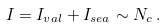Convert formula to latex. <formula><loc_0><loc_0><loc_500><loc_500>I = I _ { v a l } + I _ { s e a } \sim N _ { c } \, .</formula> 